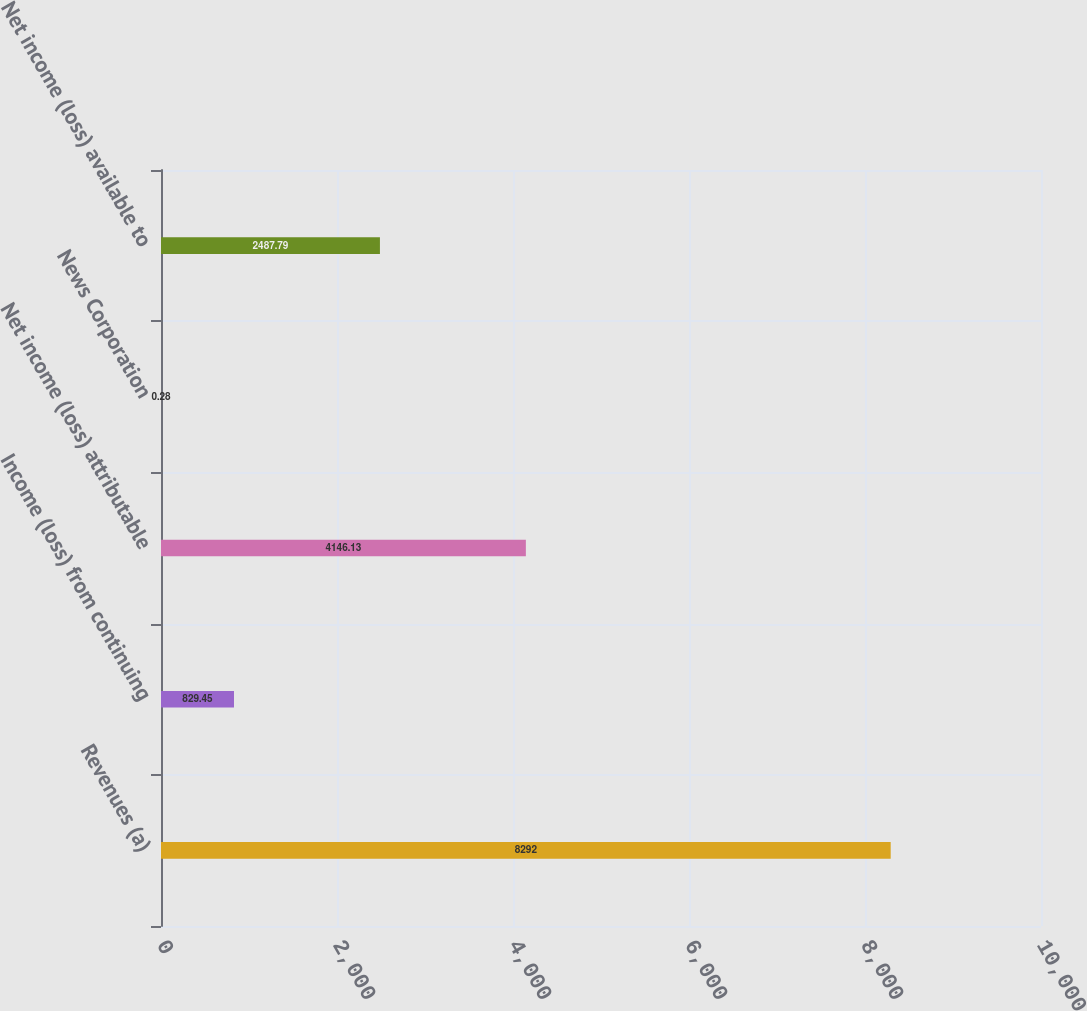Convert chart. <chart><loc_0><loc_0><loc_500><loc_500><bar_chart><fcel>Revenues (a)<fcel>Income (loss) from continuing<fcel>Net income (loss) attributable<fcel>News Corporation<fcel>Net income (loss) available to<nl><fcel>8292<fcel>829.45<fcel>4146.13<fcel>0.28<fcel>2487.79<nl></chart> 